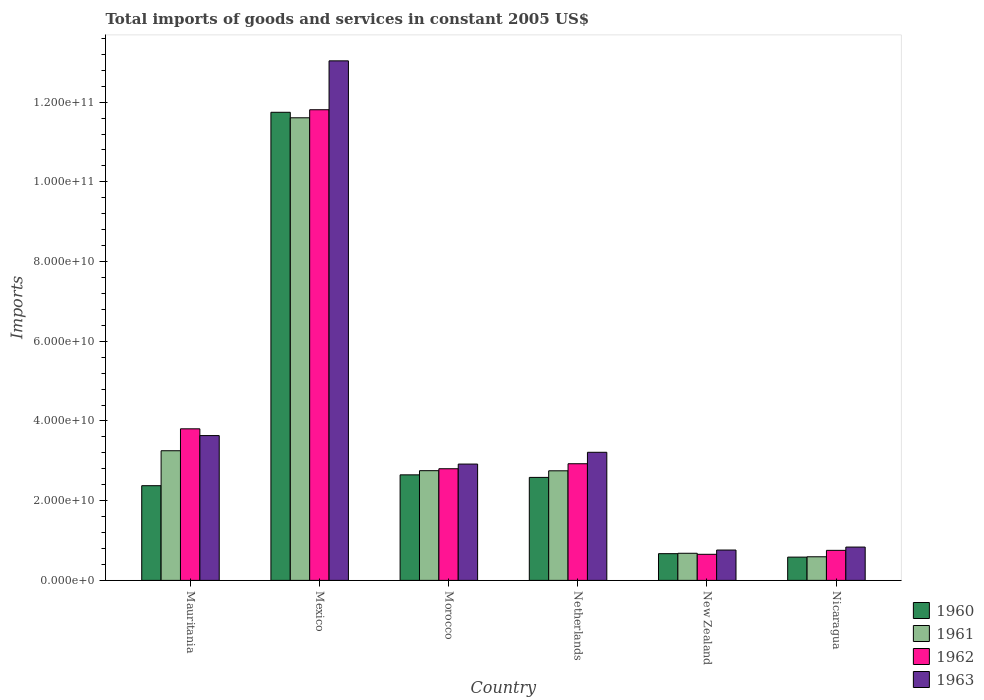Are the number of bars per tick equal to the number of legend labels?
Offer a very short reply. Yes. How many bars are there on the 1st tick from the left?
Offer a very short reply. 4. What is the label of the 6th group of bars from the left?
Provide a short and direct response. Nicaragua. In how many cases, is the number of bars for a given country not equal to the number of legend labels?
Provide a short and direct response. 0. What is the total imports of goods and services in 1963 in Mauritania?
Keep it short and to the point. 3.63e+1. Across all countries, what is the maximum total imports of goods and services in 1961?
Ensure brevity in your answer.  1.16e+11. Across all countries, what is the minimum total imports of goods and services in 1960?
Make the answer very short. 5.84e+09. In which country was the total imports of goods and services in 1960 minimum?
Your answer should be compact. Nicaragua. What is the total total imports of goods and services in 1960 in the graph?
Keep it short and to the point. 2.06e+11. What is the difference between the total imports of goods and services in 1961 in Morocco and that in Netherlands?
Keep it short and to the point. 3.12e+07. What is the difference between the total imports of goods and services in 1963 in Morocco and the total imports of goods and services in 1962 in New Zealand?
Provide a short and direct response. 2.26e+1. What is the average total imports of goods and services in 1963 per country?
Provide a short and direct response. 4.07e+1. What is the difference between the total imports of goods and services of/in 1963 and total imports of goods and services of/in 1960 in Mexico?
Provide a succinct answer. 1.29e+1. What is the ratio of the total imports of goods and services in 1963 in Mauritania to that in Mexico?
Offer a very short reply. 0.28. Is the total imports of goods and services in 1961 in Mexico less than that in Morocco?
Make the answer very short. No. What is the difference between the highest and the second highest total imports of goods and services in 1962?
Offer a very short reply. 8.88e+1. What is the difference between the highest and the lowest total imports of goods and services in 1960?
Your response must be concise. 1.12e+11. Is the sum of the total imports of goods and services in 1963 in Netherlands and New Zealand greater than the maximum total imports of goods and services in 1961 across all countries?
Give a very brief answer. No. Is it the case that in every country, the sum of the total imports of goods and services in 1961 and total imports of goods and services in 1960 is greater than the sum of total imports of goods and services in 1962 and total imports of goods and services in 1963?
Your response must be concise. No. Are all the bars in the graph horizontal?
Offer a terse response. No. What is the difference between two consecutive major ticks on the Y-axis?
Your answer should be compact. 2.00e+1. Does the graph contain any zero values?
Ensure brevity in your answer.  No. Where does the legend appear in the graph?
Your answer should be compact. Bottom right. How many legend labels are there?
Your answer should be very brief. 4. What is the title of the graph?
Keep it short and to the point. Total imports of goods and services in constant 2005 US$. What is the label or title of the X-axis?
Provide a succinct answer. Country. What is the label or title of the Y-axis?
Your answer should be compact. Imports. What is the Imports of 1960 in Mauritania?
Offer a terse response. 2.38e+1. What is the Imports in 1961 in Mauritania?
Provide a succinct answer. 3.25e+1. What is the Imports of 1962 in Mauritania?
Offer a terse response. 3.80e+1. What is the Imports in 1963 in Mauritania?
Your response must be concise. 3.63e+1. What is the Imports of 1960 in Mexico?
Your response must be concise. 1.17e+11. What is the Imports in 1961 in Mexico?
Give a very brief answer. 1.16e+11. What is the Imports of 1962 in Mexico?
Your answer should be very brief. 1.18e+11. What is the Imports of 1963 in Mexico?
Provide a succinct answer. 1.30e+11. What is the Imports in 1960 in Morocco?
Your answer should be compact. 2.65e+1. What is the Imports in 1961 in Morocco?
Provide a succinct answer. 2.75e+1. What is the Imports in 1962 in Morocco?
Make the answer very short. 2.80e+1. What is the Imports of 1963 in Morocco?
Provide a succinct answer. 2.92e+1. What is the Imports in 1960 in Netherlands?
Provide a succinct answer. 2.58e+1. What is the Imports in 1961 in Netherlands?
Your answer should be very brief. 2.75e+1. What is the Imports in 1962 in Netherlands?
Keep it short and to the point. 2.93e+1. What is the Imports of 1963 in Netherlands?
Offer a terse response. 3.21e+1. What is the Imports of 1960 in New Zealand?
Your response must be concise. 6.71e+09. What is the Imports of 1961 in New Zealand?
Your response must be concise. 6.81e+09. What is the Imports in 1962 in New Zealand?
Provide a short and direct response. 6.55e+09. What is the Imports in 1963 in New Zealand?
Make the answer very short. 7.62e+09. What is the Imports of 1960 in Nicaragua?
Keep it short and to the point. 5.84e+09. What is the Imports of 1961 in Nicaragua?
Provide a short and direct response. 5.92e+09. What is the Imports of 1962 in Nicaragua?
Offer a terse response. 7.54e+09. What is the Imports in 1963 in Nicaragua?
Provide a short and direct response. 8.36e+09. Across all countries, what is the maximum Imports in 1960?
Your answer should be compact. 1.17e+11. Across all countries, what is the maximum Imports in 1961?
Offer a very short reply. 1.16e+11. Across all countries, what is the maximum Imports in 1962?
Give a very brief answer. 1.18e+11. Across all countries, what is the maximum Imports in 1963?
Your answer should be very brief. 1.30e+11. Across all countries, what is the minimum Imports of 1960?
Provide a short and direct response. 5.84e+09. Across all countries, what is the minimum Imports of 1961?
Offer a terse response. 5.92e+09. Across all countries, what is the minimum Imports in 1962?
Your answer should be very brief. 6.55e+09. Across all countries, what is the minimum Imports of 1963?
Make the answer very short. 7.62e+09. What is the total Imports in 1960 in the graph?
Your response must be concise. 2.06e+11. What is the total Imports of 1961 in the graph?
Your answer should be compact. 2.16e+11. What is the total Imports of 1962 in the graph?
Ensure brevity in your answer.  2.27e+11. What is the total Imports of 1963 in the graph?
Make the answer very short. 2.44e+11. What is the difference between the Imports of 1960 in Mauritania and that in Mexico?
Your response must be concise. -9.37e+1. What is the difference between the Imports of 1961 in Mauritania and that in Mexico?
Provide a short and direct response. -8.35e+1. What is the difference between the Imports of 1962 in Mauritania and that in Mexico?
Make the answer very short. -8.01e+1. What is the difference between the Imports in 1963 in Mauritania and that in Mexico?
Offer a very short reply. -9.40e+1. What is the difference between the Imports of 1960 in Mauritania and that in Morocco?
Offer a very short reply. -2.72e+09. What is the difference between the Imports in 1961 in Mauritania and that in Morocco?
Your response must be concise. 5.00e+09. What is the difference between the Imports of 1962 in Mauritania and that in Morocco?
Your response must be concise. 1.00e+1. What is the difference between the Imports of 1963 in Mauritania and that in Morocco?
Your response must be concise. 7.15e+09. What is the difference between the Imports in 1960 in Mauritania and that in Netherlands?
Offer a very short reply. -2.08e+09. What is the difference between the Imports in 1961 in Mauritania and that in Netherlands?
Give a very brief answer. 5.03e+09. What is the difference between the Imports in 1962 in Mauritania and that in Netherlands?
Your answer should be compact. 8.76e+09. What is the difference between the Imports of 1963 in Mauritania and that in Netherlands?
Offer a very short reply. 4.19e+09. What is the difference between the Imports in 1960 in Mauritania and that in New Zealand?
Ensure brevity in your answer.  1.71e+1. What is the difference between the Imports in 1961 in Mauritania and that in New Zealand?
Ensure brevity in your answer.  2.57e+1. What is the difference between the Imports of 1962 in Mauritania and that in New Zealand?
Keep it short and to the point. 3.15e+1. What is the difference between the Imports in 1963 in Mauritania and that in New Zealand?
Offer a very short reply. 2.87e+1. What is the difference between the Imports in 1960 in Mauritania and that in Nicaragua?
Offer a terse response. 1.79e+1. What is the difference between the Imports in 1961 in Mauritania and that in Nicaragua?
Make the answer very short. 2.66e+1. What is the difference between the Imports of 1962 in Mauritania and that in Nicaragua?
Your answer should be very brief. 3.05e+1. What is the difference between the Imports of 1963 in Mauritania and that in Nicaragua?
Make the answer very short. 2.80e+1. What is the difference between the Imports of 1960 in Mexico and that in Morocco?
Offer a very short reply. 9.10e+1. What is the difference between the Imports of 1961 in Mexico and that in Morocco?
Offer a terse response. 8.85e+1. What is the difference between the Imports of 1962 in Mexico and that in Morocco?
Ensure brevity in your answer.  9.01e+1. What is the difference between the Imports of 1963 in Mexico and that in Morocco?
Ensure brevity in your answer.  1.01e+11. What is the difference between the Imports in 1960 in Mexico and that in Netherlands?
Give a very brief answer. 9.16e+1. What is the difference between the Imports of 1961 in Mexico and that in Netherlands?
Your response must be concise. 8.86e+1. What is the difference between the Imports of 1962 in Mexico and that in Netherlands?
Offer a terse response. 8.88e+1. What is the difference between the Imports in 1963 in Mexico and that in Netherlands?
Ensure brevity in your answer.  9.82e+1. What is the difference between the Imports in 1960 in Mexico and that in New Zealand?
Your response must be concise. 1.11e+11. What is the difference between the Imports of 1961 in Mexico and that in New Zealand?
Provide a succinct answer. 1.09e+11. What is the difference between the Imports of 1962 in Mexico and that in New Zealand?
Make the answer very short. 1.12e+11. What is the difference between the Imports of 1963 in Mexico and that in New Zealand?
Your answer should be compact. 1.23e+11. What is the difference between the Imports of 1960 in Mexico and that in Nicaragua?
Keep it short and to the point. 1.12e+11. What is the difference between the Imports of 1961 in Mexico and that in Nicaragua?
Your answer should be compact. 1.10e+11. What is the difference between the Imports in 1962 in Mexico and that in Nicaragua?
Your response must be concise. 1.11e+11. What is the difference between the Imports in 1963 in Mexico and that in Nicaragua?
Keep it short and to the point. 1.22e+11. What is the difference between the Imports in 1960 in Morocco and that in Netherlands?
Provide a short and direct response. 6.37e+08. What is the difference between the Imports of 1961 in Morocco and that in Netherlands?
Your answer should be very brief. 3.12e+07. What is the difference between the Imports of 1962 in Morocco and that in Netherlands?
Your response must be concise. -1.25e+09. What is the difference between the Imports of 1963 in Morocco and that in Netherlands?
Provide a short and direct response. -2.96e+09. What is the difference between the Imports in 1960 in Morocco and that in New Zealand?
Offer a terse response. 1.98e+1. What is the difference between the Imports in 1961 in Morocco and that in New Zealand?
Provide a short and direct response. 2.07e+1. What is the difference between the Imports of 1962 in Morocco and that in New Zealand?
Provide a short and direct response. 2.15e+1. What is the difference between the Imports in 1963 in Morocco and that in New Zealand?
Your answer should be compact. 2.16e+1. What is the difference between the Imports of 1960 in Morocco and that in Nicaragua?
Ensure brevity in your answer.  2.06e+1. What is the difference between the Imports in 1961 in Morocco and that in Nicaragua?
Your answer should be very brief. 2.16e+1. What is the difference between the Imports in 1962 in Morocco and that in Nicaragua?
Make the answer very short. 2.05e+1. What is the difference between the Imports in 1963 in Morocco and that in Nicaragua?
Keep it short and to the point. 2.08e+1. What is the difference between the Imports in 1960 in Netherlands and that in New Zealand?
Your answer should be compact. 1.91e+1. What is the difference between the Imports in 1961 in Netherlands and that in New Zealand?
Provide a succinct answer. 2.07e+1. What is the difference between the Imports in 1962 in Netherlands and that in New Zealand?
Offer a terse response. 2.27e+1. What is the difference between the Imports in 1963 in Netherlands and that in New Zealand?
Provide a succinct answer. 2.45e+1. What is the difference between the Imports in 1960 in Netherlands and that in Nicaragua?
Ensure brevity in your answer.  2.00e+1. What is the difference between the Imports in 1961 in Netherlands and that in Nicaragua?
Provide a succinct answer. 2.16e+1. What is the difference between the Imports in 1962 in Netherlands and that in Nicaragua?
Keep it short and to the point. 2.17e+1. What is the difference between the Imports of 1963 in Netherlands and that in Nicaragua?
Offer a very short reply. 2.38e+1. What is the difference between the Imports of 1960 in New Zealand and that in Nicaragua?
Offer a very short reply. 8.66e+08. What is the difference between the Imports in 1961 in New Zealand and that in Nicaragua?
Your answer should be compact. 8.81e+08. What is the difference between the Imports of 1962 in New Zealand and that in Nicaragua?
Your response must be concise. -9.91e+08. What is the difference between the Imports of 1963 in New Zealand and that in Nicaragua?
Give a very brief answer. -7.46e+08. What is the difference between the Imports in 1960 in Mauritania and the Imports in 1961 in Mexico?
Make the answer very short. -9.23e+1. What is the difference between the Imports of 1960 in Mauritania and the Imports of 1962 in Mexico?
Ensure brevity in your answer.  -9.43e+1. What is the difference between the Imports in 1960 in Mauritania and the Imports in 1963 in Mexico?
Make the answer very short. -1.07e+11. What is the difference between the Imports in 1961 in Mauritania and the Imports in 1962 in Mexico?
Offer a very short reply. -8.56e+1. What is the difference between the Imports in 1961 in Mauritania and the Imports in 1963 in Mexico?
Provide a succinct answer. -9.78e+1. What is the difference between the Imports of 1962 in Mauritania and the Imports of 1963 in Mexico?
Your response must be concise. -9.23e+1. What is the difference between the Imports of 1960 in Mauritania and the Imports of 1961 in Morocco?
Offer a very short reply. -3.77e+09. What is the difference between the Imports of 1960 in Mauritania and the Imports of 1962 in Morocco?
Offer a very short reply. -4.26e+09. What is the difference between the Imports of 1960 in Mauritania and the Imports of 1963 in Morocco?
Offer a very short reply. -5.43e+09. What is the difference between the Imports in 1961 in Mauritania and the Imports in 1962 in Morocco?
Ensure brevity in your answer.  4.51e+09. What is the difference between the Imports of 1961 in Mauritania and the Imports of 1963 in Morocco?
Give a very brief answer. 3.34e+09. What is the difference between the Imports in 1962 in Mauritania and the Imports in 1963 in Morocco?
Your response must be concise. 8.85e+09. What is the difference between the Imports in 1960 in Mauritania and the Imports in 1961 in Netherlands?
Offer a very short reply. -3.74e+09. What is the difference between the Imports in 1960 in Mauritania and the Imports in 1962 in Netherlands?
Keep it short and to the point. -5.51e+09. What is the difference between the Imports of 1960 in Mauritania and the Imports of 1963 in Netherlands?
Keep it short and to the point. -8.38e+09. What is the difference between the Imports of 1961 in Mauritania and the Imports of 1962 in Netherlands?
Your response must be concise. 3.26e+09. What is the difference between the Imports in 1961 in Mauritania and the Imports in 1963 in Netherlands?
Your response must be concise. 3.86e+08. What is the difference between the Imports in 1962 in Mauritania and the Imports in 1963 in Netherlands?
Provide a succinct answer. 5.89e+09. What is the difference between the Imports in 1960 in Mauritania and the Imports in 1961 in New Zealand?
Provide a short and direct response. 1.70e+1. What is the difference between the Imports of 1960 in Mauritania and the Imports of 1962 in New Zealand?
Keep it short and to the point. 1.72e+1. What is the difference between the Imports of 1960 in Mauritania and the Imports of 1963 in New Zealand?
Your response must be concise. 1.61e+1. What is the difference between the Imports of 1961 in Mauritania and the Imports of 1962 in New Zealand?
Ensure brevity in your answer.  2.60e+1. What is the difference between the Imports in 1961 in Mauritania and the Imports in 1963 in New Zealand?
Give a very brief answer. 2.49e+1. What is the difference between the Imports in 1962 in Mauritania and the Imports in 1963 in New Zealand?
Give a very brief answer. 3.04e+1. What is the difference between the Imports in 1960 in Mauritania and the Imports in 1961 in Nicaragua?
Provide a succinct answer. 1.78e+1. What is the difference between the Imports of 1960 in Mauritania and the Imports of 1962 in Nicaragua?
Provide a short and direct response. 1.62e+1. What is the difference between the Imports in 1960 in Mauritania and the Imports in 1963 in Nicaragua?
Provide a succinct answer. 1.54e+1. What is the difference between the Imports in 1961 in Mauritania and the Imports in 1962 in Nicaragua?
Make the answer very short. 2.50e+1. What is the difference between the Imports of 1961 in Mauritania and the Imports of 1963 in Nicaragua?
Give a very brief answer. 2.42e+1. What is the difference between the Imports in 1962 in Mauritania and the Imports in 1963 in Nicaragua?
Your answer should be compact. 2.97e+1. What is the difference between the Imports of 1960 in Mexico and the Imports of 1961 in Morocco?
Offer a terse response. 8.99e+1. What is the difference between the Imports in 1960 in Mexico and the Imports in 1962 in Morocco?
Keep it short and to the point. 8.94e+1. What is the difference between the Imports of 1960 in Mexico and the Imports of 1963 in Morocco?
Offer a very short reply. 8.83e+1. What is the difference between the Imports in 1961 in Mexico and the Imports in 1962 in Morocco?
Your response must be concise. 8.81e+1. What is the difference between the Imports in 1961 in Mexico and the Imports in 1963 in Morocco?
Your response must be concise. 8.69e+1. What is the difference between the Imports of 1962 in Mexico and the Imports of 1963 in Morocco?
Your response must be concise. 8.89e+1. What is the difference between the Imports in 1960 in Mexico and the Imports in 1961 in Netherlands?
Provide a succinct answer. 9.00e+1. What is the difference between the Imports in 1960 in Mexico and the Imports in 1962 in Netherlands?
Provide a short and direct response. 8.82e+1. What is the difference between the Imports in 1960 in Mexico and the Imports in 1963 in Netherlands?
Provide a short and direct response. 8.53e+1. What is the difference between the Imports in 1961 in Mexico and the Imports in 1962 in Netherlands?
Your answer should be very brief. 8.68e+1. What is the difference between the Imports in 1961 in Mexico and the Imports in 1963 in Netherlands?
Provide a succinct answer. 8.39e+1. What is the difference between the Imports in 1962 in Mexico and the Imports in 1963 in Netherlands?
Provide a short and direct response. 8.59e+1. What is the difference between the Imports in 1960 in Mexico and the Imports in 1961 in New Zealand?
Make the answer very short. 1.11e+11. What is the difference between the Imports in 1960 in Mexico and the Imports in 1962 in New Zealand?
Provide a short and direct response. 1.11e+11. What is the difference between the Imports in 1960 in Mexico and the Imports in 1963 in New Zealand?
Your answer should be compact. 1.10e+11. What is the difference between the Imports in 1961 in Mexico and the Imports in 1962 in New Zealand?
Ensure brevity in your answer.  1.10e+11. What is the difference between the Imports in 1961 in Mexico and the Imports in 1963 in New Zealand?
Make the answer very short. 1.08e+11. What is the difference between the Imports in 1962 in Mexico and the Imports in 1963 in New Zealand?
Keep it short and to the point. 1.10e+11. What is the difference between the Imports of 1960 in Mexico and the Imports of 1961 in Nicaragua?
Give a very brief answer. 1.12e+11. What is the difference between the Imports in 1960 in Mexico and the Imports in 1962 in Nicaragua?
Provide a short and direct response. 1.10e+11. What is the difference between the Imports of 1960 in Mexico and the Imports of 1963 in Nicaragua?
Make the answer very short. 1.09e+11. What is the difference between the Imports in 1961 in Mexico and the Imports in 1962 in Nicaragua?
Your answer should be compact. 1.09e+11. What is the difference between the Imports of 1961 in Mexico and the Imports of 1963 in Nicaragua?
Your response must be concise. 1.08e+11. What is the difference between the Imports in 1962 in Mexico and the Imports in 1963 in Nicaragua?
Your answer should be very brief. 1.10e+11. What is the difference between the Imports of 1960 in Morocco and the Imports of 1961 in Netherlands?
Your response must be concise. -1.02e+09. What is the difference between the Imports in 1960 in Morocco and the Imports in 1962 in Netherlands?
Offer a very short reply. -2.79e+09. What is the difference between the Imports in 1960 in Morocco and the Imports in 1963 in Netherlands?
Give a very brief answer. -5.66e+09. What is the difference between the Imports of 1961 in Morocco and the Imports of 1962 in Netherlands?
Give a very brief answer. -1.74e+09. What is the difference between the Imports of 1961 in Morocco and the Imports of 1963 in Netherlands?
Offer a terse response. -4.62e+09. What is the difference between the Imports of 1962 in Morocco and the Imports of 1963 in Netherlands?
Ensure brevity in your answer.  -4.13e+09. What is the difference between the Imports of 1960 in Morocco and the Imports of 1961 in New Zealand?
Keep it short and to the point. 1.97e+1. What is the difference between the Imports in 1960 in Morocco and the Imports in 1962 in New Zealand?
Ensure brevity in your answer.  1.99e+1. What is the difference between the Imports in 1960 in Morocco and the Imports in 1963 in New Zealand?
Make the answer very short. 1.89e+1. What is the difference between the Imports of 1961 in Morocco and the Imports of 1962 in New Zealand?
Your response must be concise. 2.10e+1. What is the difference between the Imports of 1961 in Morocco and the Imports of 1963 in New Zealand?
Offer a terse response. 1.99e+1. What is the difference between the Imports in 1962 in Morocco and the Imports in 1963 in New Zealand?
Your answer should be compact. 2.04e+1. What is the difference between the Imports in 1960 in Morocco and the Imports in 1961 in Nicaragua?
Offer a very short reply. 2.06e+1. What is the difference between the Imports in 1960 in Morocco and the Imports in 1962 in Nicaragua?
Keep it short and to the point. 1.89e+1. What is the difference between the Imports of 1960 in Morocco and the Imports of 1963 in Nicaragua?
Offer a terse response. 1.81e+1. What is the difference between the Imports of 1961 in Morocco and the Imports of 1962 in Nicaragua?
Your answer should be very brief. 2.00e+1. What is the difference between the Imports in 1961 in Morocco and the Imports in 1963 in Nicaragua?
Give a very brief answer. 1.92e+1. What is the difference between the Imports of 1962 in Morocco and the Imports of 1963 in Nicaragua?
Your response must be concise. 1.97e+1. What is the difference between the Imports of 1960 in Netherlands and the Imports of 1961 in New Zealand?
Your answer should be very brief. 1.90e+1. What is the difference between the Imports in 1960 in Netherlands and the Imports in 1962 in New Zealand?
Make the answer very short. 1.93e+1. What is the difference between the Imports of 1960 in Netherlands and the Imports of 1963 in New Zealand?
Provide a short and direct response. 1.82e+1. What is the difference between the Imports in 1961 in Netherlands and the Imports in 1962 in New Zealand?
Your answer should be compact. 2.10e+1. What is the difference between the Imports of 1961 in Netherlands and the Imports of 1963 in New Zealand?
Your answer should be very brief. 1.99e+1. What is the difference between the Imports of 1962 in Netherlands and the Imports of 1963 in New Zealand?
Your answer should be very brief. 2.17e+1. What is the difference between the Imports in 1960 in Netherlands and the Imports in 1961 in Nicaragua?
Your answer should be very brief. 1.99e+1. What is the difference between the Imports of 1960 in Netherlands and the Imports of 1962 in Nicaragua?
Keep it short and to the point. 1.83e+1. What is the difference between the Imports in 1960 in Netherlands and the Imports in 1963 in Nicaragua?
Your answer should be very brief. 1.75e+1. What is the difference between the Imports in 1961 in Netherlands and the Imports in 1962 in Nicaragua?
Give a very brief answer. 2.00e+1. What is the difference between the Imports in 1961 in Netherlands and the Imports in 1963 in Nicaragua?
Your response must be concise. 1.91e+1. What is the difference between the Imports of 1962 in Netherlands and the Imports of 1963 in Nicaragua?
Your response must be concise. 2.09e+1. What is the difference between the Imports of 1960 in New Zealand and the Imports of 1961 in Nicaragua?
Your response must be concise. 7.83e+08. What is the difference between the Imports in 1960 in New Zealand and the Imports in 1962 in Nicaragua?
Your answer should be very brief. -8.30e+08. What is the difference between the Imports of 1960 in New Zealand and the Imports of 1963 in Nicaragua?
Keep it short and to the point. -1.66e+09. What is the difference between the Imports of 1961 in New Zealand and the Imports of 1962 in Nicaragua?
Provide a succinct answer. -7.32e+08. What is the difference between the Imports in 1961 in New Zealand and the Imports in 1963 in Nicaragua?
Your answer should be compact. -1.56e+09. What is the difference between the Imports of 1962 in New Zealand and the Imports of 1963 in Nicaragua?
Give a very brief answer. -1.82e+09. What is the average Imports of 1960 per country?
Your answer should be very brief. 3.43e+1. What is the average Imports in 1961 per country?
Your answer should be very brief. 3.61e+1. What is the average Imports of 1962 per country?
Provide a short and direct response. 3.79e+1. What is the average Imports in 1963 per country?
Make the answer very short. 4.07e+1. What is the difference between the Imports in 1960 and Imports in 1961 in Mauritania?
Keep it short and to the point. -8.77e+09. What is the difference between the Imports in 1960 and Imports in 1962 in Mauritania?
Your answer should be very brief. -1.43e+1. What is the difference between the Imports in 1960 and Imports in 1963 in Mauritania?
Your answer should be very brief. -1.26e+1. What is the difference between the Imports of 1961 and Imports of 1962 in Mauritania?
Keep it short and to the point. -5.50e+09. What is the difference between the Imports of 1961 and Imports of 1963 in Mauritania?
Your answer should be very brief. -3.80e+09. What is the difference between the Imports in 1962 and Imports in 1963 in Mauritania?
Your answer should be compact. 1.70e+09. What is the difference between the Imports of 1960 and Imports of 1961 in Mexico?
Ensure brevity in your answer.  1.38e+09. What is the difference between the Imports of 1960 and Imports of 1962 in Mexico?
Ensure brevity in your answer.  -6.38e+08. What is the difference between the Imports of 1960 and Imports of 1963 in Mexico?
Make the answer very short. -1.29e+1. What is the difference between the Imports of 1961 and Imports of 1962 in Mexico?
Offer a very short reply. -2.02e+09. What is the difference between the Imports in 1961 and Imports in 1963 in Mexico?
Ensure brevity in your answer.  -1.43e+1. What is the difference between the Imports of 1962 and Imports of 1963 in Mexico?
Provide a succinct answer. -1.23e+1. What is the difference between the Imports of 1960 and Imports of 1961 in Morocco?
Give a very brief answer. -1.05e+09. What is the difference between the Imports in 1960 and Imports in 1962 in Morocco?
Provide a short and direct response. -1.54e+09. What is the difference between the Imports in 1960 and Imports in 1963 in Morocco?
Your response must be concise. -2.70e+09. What is the difference between the Imports of 1961 and Imports of 1962 in Morocco?
Make the answer very short. -4.88e+08. What is the difference between the Imports in 1961 and Imports in 1963 in Morocco?
Offer a terse response. -1.66e+09. What is the difference between the Imports in 1962 and Imports in 1963 in Morocco?
Ensure brevity in your answer.  -1.17e+09. What is the difference between the Imports of 1960 and Imports of 1961 in Netherlands?
Make the answer very short. -1.65e+09. What is the difference between the Imports of 1960 and Imports of 1962 in Netherlands?
Keep it short and to the point. -3.43e+09. What is the difference between the Imports in 1960 and Imports in 1963 in Netherlands?
Provide a short and direct response. -6.30e+09. What is the difference between the Imports in 1961 and Imports in 1962 in Netherlands?
Provide a succinct answer. -1.77e+09. What is the difference between the Imports of 1961 and Imports of 1963 in Netherlands?
Offer a terse response. -4.65e+09. What is the difference between the Imports in 1962 and Imports in 1963 in Netherlands?
Give a very brief answer. -2.87e+09. What is the difference between the Imports in 1960 and Imports in 1961 in New Zealand?
Give a very brief answer. -9.87e+07. What is the difference between the Imports in 1960 and Imports in 1962 in New Zealand?
Give a very brief answer. 1.61e+08. What is the difference between the Imports in 1960 and Imports in 1963 in New Zealand?
Offer a terse response. -9.09e+08. What is the difference between the Imports of 1961 and Imports of 1962 in New Zealand?
Give a very brief answer. 2.60e+08. What is the difference between the Imports of 1961 and Imports of 1963 in New Zealand?
Your answer should be very brief. -8.10e+08. What is the difference between the Imports of 1962 and Imports of 1963 in New Zealand?
Make the answer very short. -1.07e+09. What is the difference between the Imports in 1960 and Imports in 1961 in Nicaragua?
Your answer should be compact. -8.34e+07. What is the difference between the Imports of 1960 and Imports of 1962 in Nicaragua?
Ensure brevity in your answer.  -1.70e+09. What is the difference between the Imports in 1960 and Imports in 1963 in Nicaragua?
Make the answer very short. -2.52e+09. What is the difference between the Imports of 1961 and Imports of 1962 in Nicaragua?
Your answer should be compact. -1.61e+09. What is the difference between the Imports of 1961 and Imports of 1963 in Nicaragua?
Give a very brief answer. -2.44e+09. What is the difference between the Imports in 1962 and Imports in 1963 in Nicaragua?
Provide a short and direct response. -8.25e+08. What is the ratio of the Imports of 1960 in Mauritania to that in Mexico?
Make the answer very short. 0.2. What is the ratio of the Imports of 1961 in Mauritania to that in Mexico?
Offer a terse response. 0.28. What is the ratio of the Imports in 1962 in Mauritania to that in Mexico?
Provide a short and direct response. 0.32. What is the ratio of the Imports of 1963 in Mauritania to that in Mexico?
Your answer should be very brief. 0.28. What is the ratio of the Imports of 1960 in Mauritania to that in Morocco?
Your answer should be compact. 0.9. What is the ratio of the Imports in 1961 in Mauritania to that in Morocco?
Ensure brevity in your answer.  1.18. What is the ratio of the Imports of 1962 in Mauritania to that in Morocco?
Give a very brief answer. 1.36. What is the ratio of the Imports of 1963 in Mauritania to that in Morocco?
Offer a terse response. 1.24. What is the ratio of the Imports of 1960 in Mauritania to that in Netherlands?
Give a very brief answer. 0.92. What is the ratio of the Imports in 1961 in Mauritania to that in Netherlands?
Provide a succinct answer. 1.18. What is the ratio of the Imports of 1962 in Mauritania to that in Netherlands?
Your answer should be very brief. 1.3. What is the ratio of the Imports of 1963 in Mauritania to that in Netherlands?
Make the answer very short. 1.13. What is the ratio of the Imports in 1960 in Mauritania to that in New Zealand?
Offer a terse response. 3.54. What is the ratio of the Imports in 1961 in Mauritania to that in New Zealand?
Give a very brief answer. 4.78. What is the ratio of the Imports of 1962 in Mauritania to that in New Zealand?
Give a very brief answer. 5.81. What is the ratio of the Imports in 1963 in Mauritania to that in New Zealand?
Provide a succinct answer. 4.77. What is the ratio of the Imports of 1960 in Mauritania to that in Nicaragua?
Give a very brief answer. 4.07. What is the ratio of the Imports in 1961 in Mauritania to that in Nicaragua?
Provide a short and direct response. 5.49. What is the ratio of the Imports in 1962 in Mauritania to that in Nicaragua?
Ensure brevity in your answer.  5.05. What is the ratio of the Imports of 1963 in Mauritania to that in Nicaragua?
Your response must be concise. 4.34. What is the ratio of the Imports in 1960 in Mexico to that in Morocco?
Your answer should be very brief. 4.44. What is the ratio of the Imports of 1961 in Mexico to that in Morocco?
Offer a terse response. 4.22. What is the ratio of the Imports of 1962 in Mexico to that in Morocco?
Your response must be concise. 4.22. What is the ratio of the Imports of 1963 in Mexico to that in Morocco?
Provide a short and direct response. 4.47. What is the ratio of the Imports in 1960 in Mexico to that in Netherlands?
Ensure brevity in your answer.  4.54. What is the ratio of the Imports of 1961 in Mexico to that in Netherlands?
Your response must be concise. 4.22. What is the ratio of the Imports of 1962 in Mexico to that in Netherlands?
Offer a terse response. 4.03. What is the ratio of the Imports in 1963 in Mexico to that in Netherlands?
Your answer should be very brief. 4.06. What is the ratio of the Imports in 1960 in Mexico to that in New Zealand?
Your answer should be compact. 17.51. What is the ratio of the Imports in 1961 in Mexico to that in New Zealand?
Provide a short and direct response. 17.06. What is the ratio of the Imports of 1962 in Mexico to that in New Zealand?
Ensure brevity in your answer.  18.04. What is the ratio of the Imports of 1963 in Mexico to that in New Zealand?
Provide a short and direct response. 17.12. What is the ratio of the Imports of 1960 in Mexico to that in Nicaragua?
Offer a terse response. 20.11. What is the ratio of the Imports in 1961 in Mexico to that in Nicaragua?
Your answer should be very brief. 19.59. What is the ratio of the Imports of 1962 in Mexico to that in Nicaragua?
Ensure brevity in your answer.  15.67. What is the ratio of the Imports of 1963 in Mexico to that in Nicaragua?
Provide a succinct answer. 15.59. What is the ratio of the Imports of 1960 in Morocco to that in Netherlands?
Ensure brevity in your answer.  1.02. What is the ratio of the Imports in 1962 in Morocco to that in Netherlands?
Offer a terse response. 0.96. What is the ratio of the Imports in 1963 in Morocco to that in Netherlands?
Make the answer very short. 0.91. What is the ratio of the Imports in 1960 in Morocco to that in New Zealand?
Provide a short and direct response. 3.95. What is the ratio of the Imports of 1961 in Morocco to that in New Zealand?
Your answer should be very brief. 4.04. What is the ratio of the Imports of 1962 in Morocco to that in New Zealand?
Keep it short and to the point. 4.28. What is the ratio of the Imports in 1963 in Morocco to that in New Zealand?
Your answer should be very brief. 3.83. What is the ratio of the Imports in 1960 in Morocco to that in Nicaragua?
Your response must be concise. 4.53. What is the ratio of the Imports of 1961 in Morocco to that in Nicaragua?
Your answer should be compact. 4.65. What is the ratio of the Imports in 1962 in Morocco to that in Nicaragua?
Provide a short and direct response. 3.72. What is the ratio of the Imports of 1963 in Morocco to that in Nicaragua?
Offer a terse response. 3.49. What is the ratio of the Imports in 1960 in Netherlands to that in New Zealand?
Keep it short and to the point. 3.85. What is the ratio of the Imports in 1961 in Netherlands to that in New Zealand?
Give a very brief answer. 4.04. What is the ratio of the Imports of 1962 in Netherlands to that in New Zealand?
Give a very brief answer. 4.47. What is the ratio of the Imports of 1963 in Netherlands to that in New Zealand?
Offer a very short reply. 4.22. What is the ratio of the Imports of 1960 in Netherlands to that in Nicaragua?
Keep it short and to the point. 4.42. What is the ratio of the Imports of 1961 in Netherlands to that in Nicaragua?
Your answer should be compact. 4.64. What is the ratio of the Imports in 1962 in Netherlands to that in Nicaragua?
Offer a very short reply. 3.88. What is the ratio of the Imports of 1963 in Netherlands to that in Nicaragua?
Make the answer very short. 3.84. What is the ratio of the Imports in 1960 in New Zealand to that in Nicaragua?
Provide a short and direct response. 1.15. What is the ratio of the Imports in 1961 in New Zealand to that in Nicaragua?
Keep it short and to the point. 1.15. What is the ratio of the Imports in 1962 in New Zealand to that in Nicaragua?
Give a very brief answer. 0.87. What is the ratio of the Imports in 1963 in New Zealand to that in Nicaragua?
Offer a terse response. 0.91. What is the difference between the highest and the second highest Imports in 1960?
Make the answer very short. 9.10e+1. What is the difference between the highest and the second highest Imports of 1961?
Your answer should be compact. 8.35e+1. What is the difference between the highest and the second highest Imports of 1962?
Give a very brief answer. 8.01e+1. What is the difference between the highest and the second highest Imports of 1963?
Provide a short and direct response. 9.40e+1. What is the difference between the highest and the lowest Imports in 1960?
Offer a terse response. 1.12e+11. What is the difference between the highest and the lowest Imports in 1961?
Provide a succinct answer. 1.10e+11. What is the difference between the highest and the lowest Imports of 1962?
Give a very brief answer. 1.12e+11. What is the difference between the highest and the lowest Imports of 1963?
Offer a very short reply. 1.23e+11. 